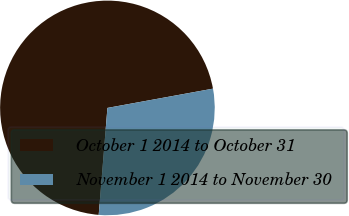Convert chart. <chart><loc_0><loc_0><loc_500><loc_500><pie_chart><fcel>October 1 2014 to October 31<fcel>November 1 2014 to November 30<nl><fcel>70.83%<fcel>29.17%<nl></chart> 